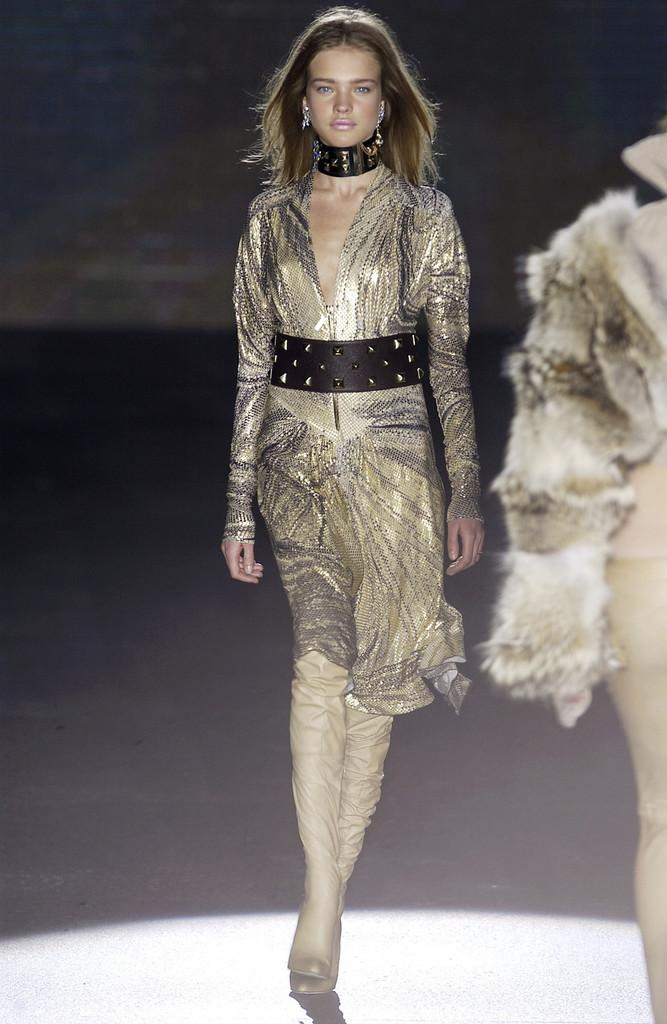What is the main subject of the image? There is a lady walking in the center of the image. Can you describe the other person in the image? There is a person on the right side of the image. What can be seen in the background of the image? There is a wall in the background of the image. What type of trees can be seen in the downtown area of the image? There are no trees or downtown area mentioned in the image; it only features a lady walking and a person on the right side, with a wall in the background. 